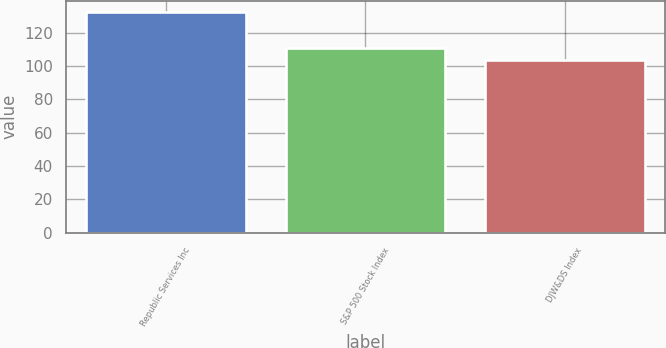<chart> <loc_0><loc_0><loc_500><loc_500><bar_chart><fcel>Republic Services Inc<fcel>S&P 500 Stock Index<fcel>DJW&DS Index<nl><fcel>132.45<fcel>110.88<fcel>103.45<nl></chart> 